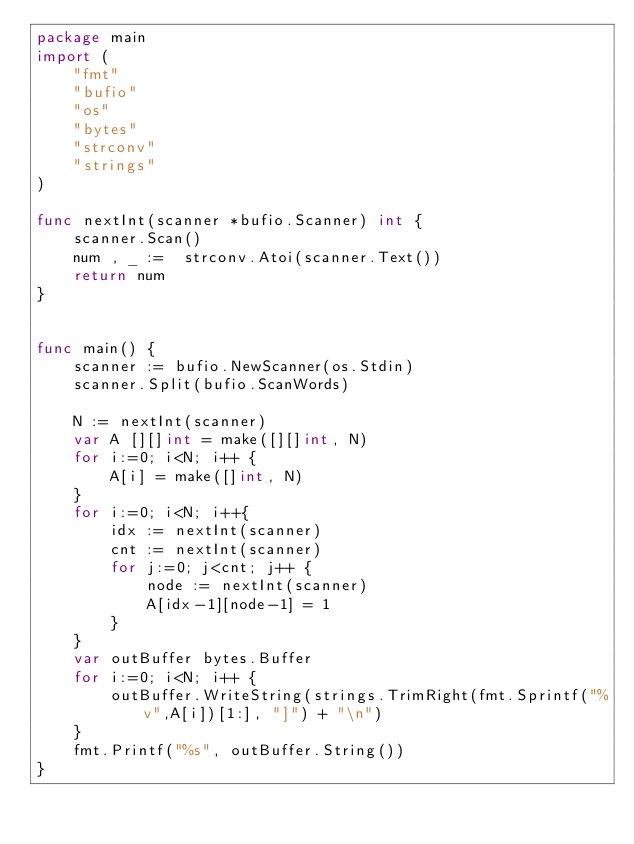Convert code to text. <code><loc_0><loc_0><loc_500><loc_500><_Go_>package main
import (
	"fmt"
	"bufio"
	"os"
	"bytes"
	"strconv"
	"strings"
)

func nextInt(scanner *bufio.Scanner) int {
	scanner.Scan()
	num , _ :=  strconv.Atoi(scanner.Text())
	return num
}


func main() {
	scanner := bufio.NewScanner(os.Stdin)
	scanner.Split(bufio.ScanWords)

	N := nextInt(scanner)
	var A [][]int = make([][]int, N)
	for i:=0; i<N; i++ {
		A[i] = make([]int, N)
	}
	for i:=0; i<N; i++{
		idx := nextInt(scanner)
		cnt := nextInt(scanner)
		for j:=0; j<cnt; j++ {
			node := nextInt(scanner)
			A[idx-1][node-1] = 1
		}
	}
	var outBuffer bytes.Buffer
	for i:=0; i<N; i++ {
		outBuffer.WriteString(strings.TrimRight(fmt.Sprintf("%v",A[i])[1:], "]") + "\n")
	}
	fmt.Printf("%s", outBuffer.String())
}
</code> 